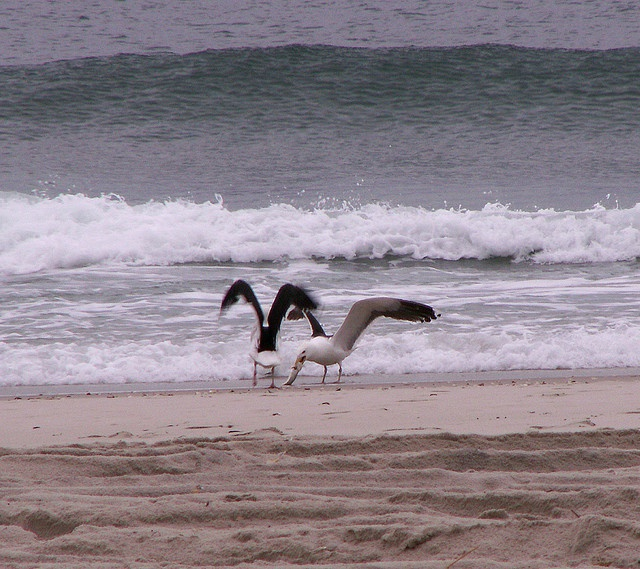Describe the objects in this image and their specific colors. I can see bird in gray, black, and darkgray tones and bird in gray, black, and darkgray tones in this image. 